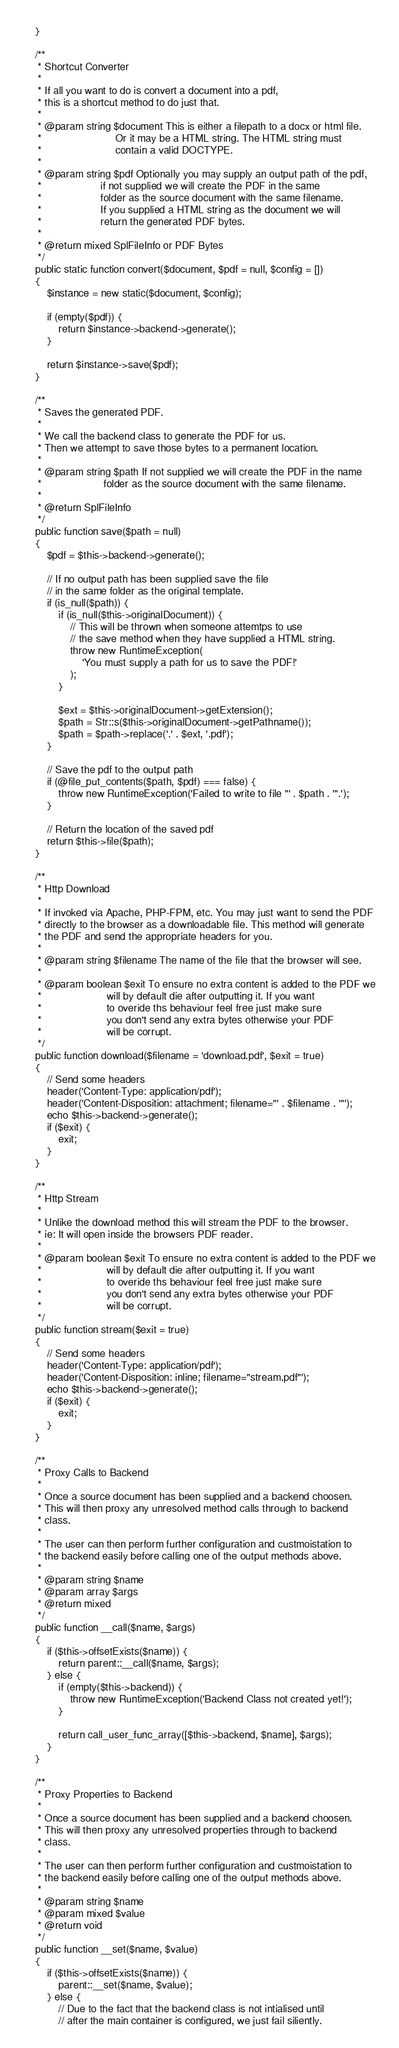<code> <loc_0><loc_0><loc_500><loc_500><_PHP_>    }

    /**
     * Shortcut Converter
     *
     * If all you want to do is convert a document into a pdf,
     * this is a shortcut method to do just that.
     *
     * @param string $document This is either a filepath to a docx or html file.
     *                         Or it may be a HTML string. The HTML string must
     *                         contain a valid DOCTYPE.
     *
     * @param string $pdf Optionally you may supply an output path of the pdf,
     *                    if not supplied we will create the PDF in the same
     *                    folder as the source document with the same filename.
     *                    If you supplied a HTML string as the document we will
     *                    return the generated PDF bytes.
     *
     * @return mixed SplFileInfo or PDF Bytes
     */
    public static function convert($document, $pdf = null, $config = [])
    {
        $instance = new static($document, $config);

        if (empty($pdf)) {
            return $instance->backend->generate();
        }

        return $instance->save($pdf);
    }

    /**
     * Saves the generated PDF.
     *
     * We call the backend class to generate the PDF for us.
     * Then we attempt to save those bytes to a permanent location.
     *
     * @param string $path If not supplied we will create the PDF in the name
     *                     folder as the source document with the same filename.
     *
     * @return SplFileInfo
     */
    public function save($path = null)
    {
        $pdf = $this->backend->generate();

        // If no output path has been supplied save the file
        // in the same folder as the original template.
        if (is_null($path)) {
            if (is_null($this->originalDocument)) {
                // This will be thrown when someone attemtps to use
                // the save method when they have supplied a HTML string.
                throw new RuntimeException(
                    'You must supply a path for us to save the PDF!'
                );
            }

            $ext = $this->originalDocument->getExtension();
            $path = Str::s($this->originalDocument->getPathname());
            $path = $path->replace('.' . $ext, '.pdf');
        }

        // Save the pdf to the output path
        if (@file_put_contents($path, $pdf) === false) {
            throw new RuntimeException('Failed to write to file "' . $path . '".');
        }

        // Return the location of the saved pdf
        return $this->file($path);
    }

    /**
     * Http Download
     *
     * If invoked via Apache, PHP-FPM, etc. You may just want to send the PDF
     * directly to the browser as a downloadable file. This method will generate
     * the PDF and send the appropriate headers for you.
     *
     * @param string $filename The name of the file that the browser will see.
     *
     * @param boolean $exit To ensure no extra content is added to the PDF we
     *                      will by default die after outputting it. If you want
     *                      to overide ths behaviour feel free just make sure
     *                      you don't send any extra bytes otherwise your PDF
     *                      will be corrupt.
     */
    public function download($filename = 'download.pdf', $exit = true)
    {
        // Send some headers
        header('Content-Type: application/pdf');
        header('Content-Disposition: attachment; filename="' . $filename . '"');
        echo $this->backend->generate();
        if ($exit) {
            exit;
        }
    }

    /**
     * Http Stream
     *
     * Unlike the download method this will stream the PDF to the browser.
     * ie: It will open inside the browsers PDF reader.
     *
     * @param boolean $exit To ensure no extra content is added to the PDF we
     *                      will by default die after outputting it. If you want
     *                      to overide ths behaviour feel free just make sure
     *                      you don't send any extra bytes otherwise your PDF
     *                      will be corrupt.
     */
    public function stream($exit = true)
    {
        // Send some headers
        header('Content-Type: application/pdf');
        header('Content-Disposition: inline; filename="stream.pdf"');
        echo $this->backend->generate();
        if ($exit) {
            exit;
        }
    }

    /**
     * Proxy Calls to Backend
     *
     * Once a source document has been supplied and a backend choosen.
     * This will then proxy any unresolved method calls through to backend
     * class.
     *
     * The user can then perform further configuration and custmoistation to
     * the backend easily before calling one of the output methods above.
     *
     * @param string $name
     * @param array $args
     * @return mixed
     */
    public function __call($name, $args)
    {
        if ($this->offsetExists($name)) {
            return parent::__call($name, $args);
        } else {
            if (empty($this->backend)) {
                throw new RuntimeException('Backend Class not created yet!');
            }

            return call_user_func_array([$this->backend, $name], $args);
        }
    }

    /**
     * Proxy Properties to Backend
     *
     * Once a source document has been supplied and a backend choosen.
     * This will then proxy any unresolved properties through to backend
     * class.
     *
     * The user can then perform further configuration and custmoistation to
     * the backend easily before calling one of the output methods above.
     *
     * @param string $name
     * @param mixed $value
     * @return void
     */
    public function __set($name, $value)
    {
        if ($this->offsetExists($name)) {
            parent::__set($name, $value);
        } else {
            // Due to the fact that the backend class is not intialised until
            // after the main container is configured, we just fail siliently.</code> 